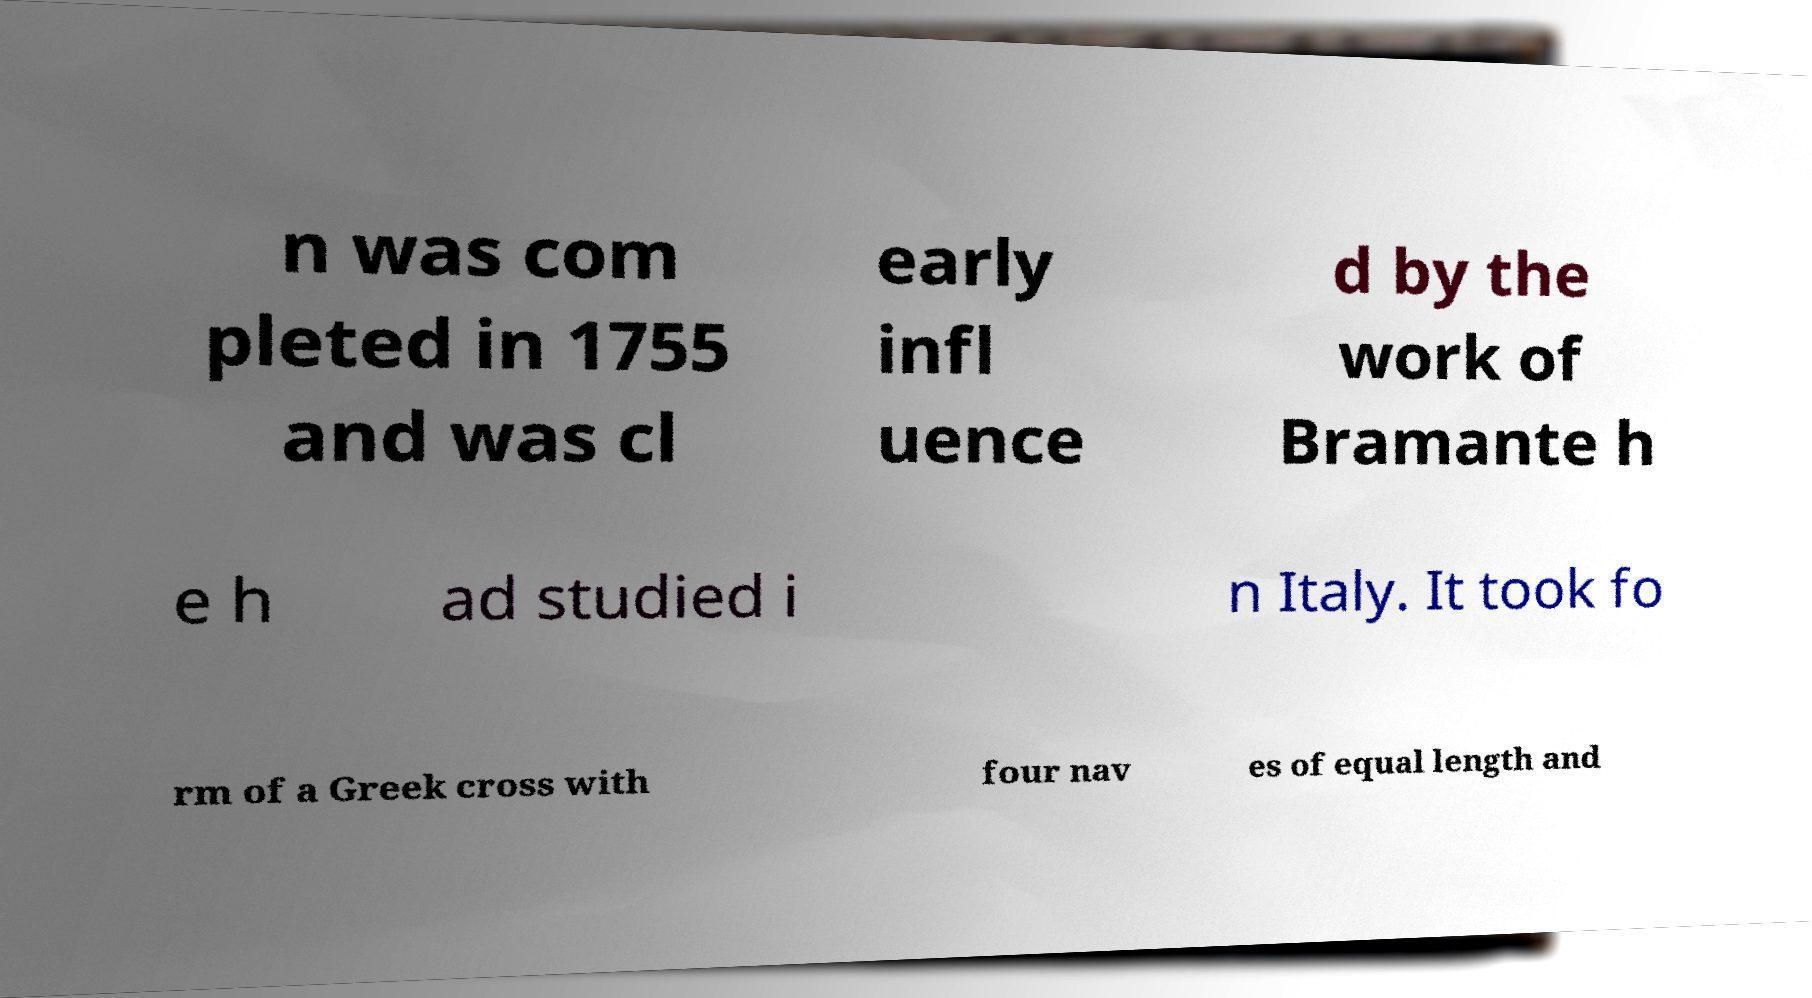I need the written content from this picture converted into text. Can you do that? n was com pleted in 1755 and was cl early infl uence d by the work of Bramante h e h ad studied i n Italy. It took fo rm of a Greek cross with four nav es of equal length and 